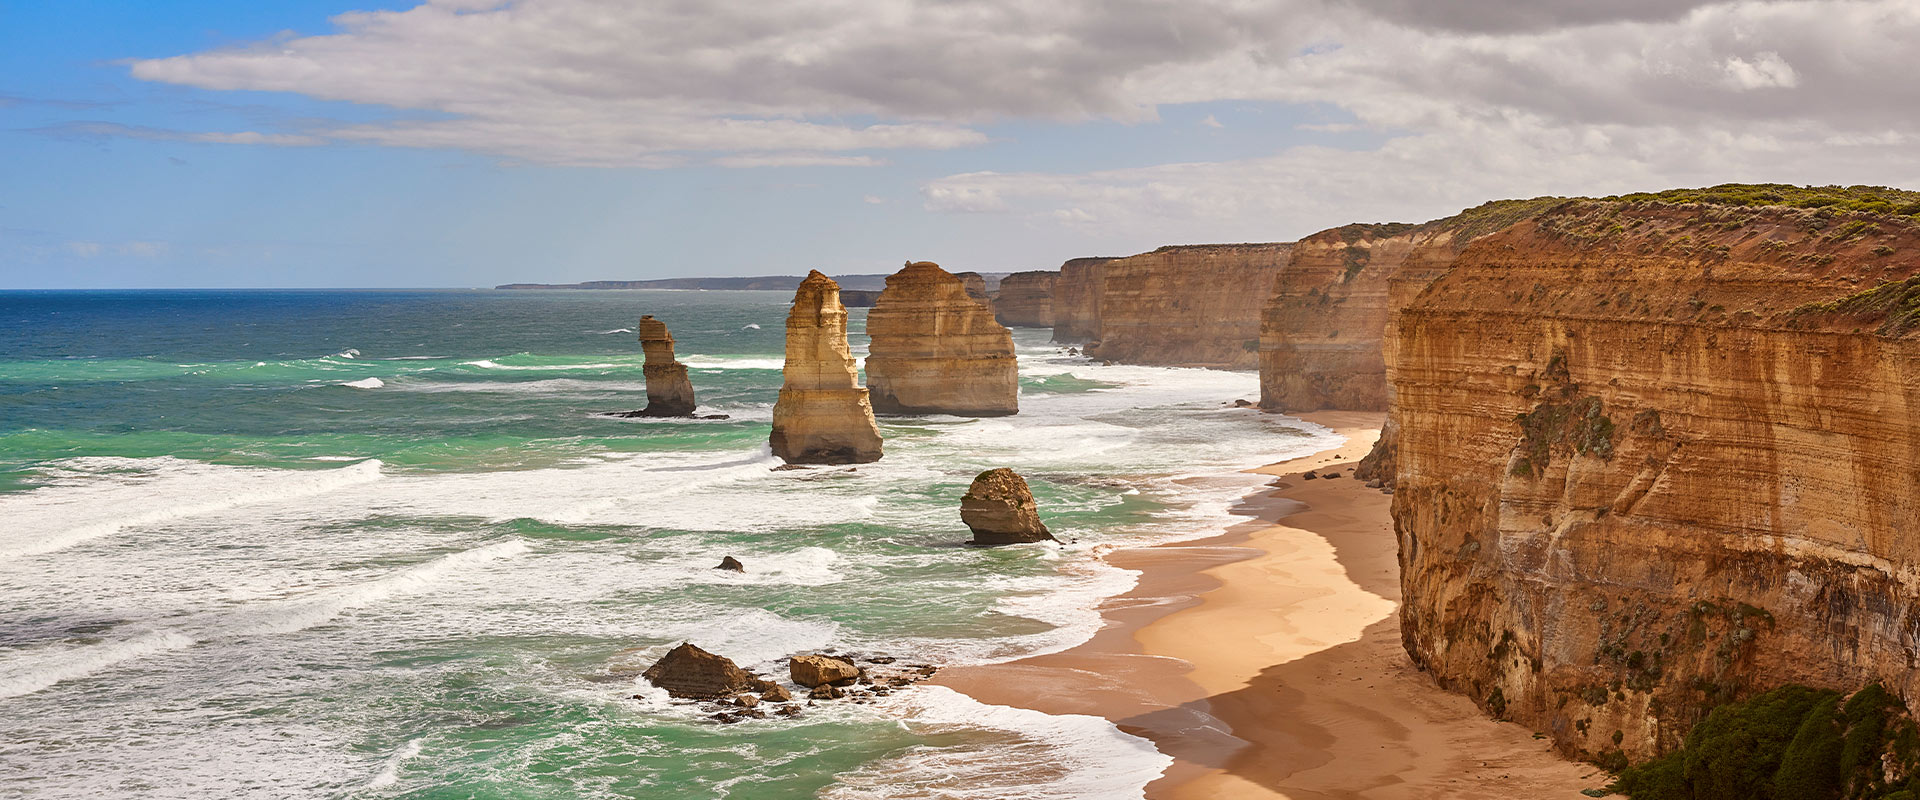How have the Twelve Apostles formed over time, and what natural processes are involved? The Twelve Apostles are formed by the erosion of limestone cliffs, which is a result of the relentless wave action from the Southern Ocean. This process, called coastal erosion, involves the sea gradually wearing away the cliff face causing caves to form, which eventually grow into arches. Over time, these arches collapse leaving isolated pillars of limestone, known as stacks. Continuous erosion at their bases even causes these stacks to fall, illustrating a dynamic, ever-changing coastline. 